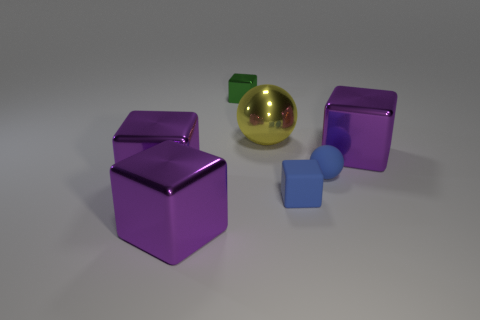Is the material of the green object the same as the small block that is on the right side of the green metallic thing?
Offer a terse response. No. What number of objects are metallic cubes that are in front of the blue matte cube or tiny things in front of the big yellow object?
Make the answer very short. 3. What number of other things are there of the same color as the small sphere?
Your answer should be very brief. 1. Are there more green metal cubes on the right side of the tiny blue matte cube than big things in front of the large yellow object?
Provide a short and direct response. No. Is there any other thing that is the same size as the rubber cube?
Keep it short and to the point. Yes. How many blocks are tiny blue objects or big purple metallic objects?
Your answer should be very brief. 4. How many objects are either large purple objects that are on the left side of the blue sphere or tiny metal cylinders?
Offer a terse response. 2. There is a large purple metallic thing that is on the right side of the small thing behind the purple shiny object that is right of the tiny shiny thing; what is its shape?
Provide a succinct answer. Cube. What number of blue matte things are the same shape as the small green object?
Keep it short and to the point. 1. Are the small sphere and the green block made of the same material?
Provide a short and direct response. No. 